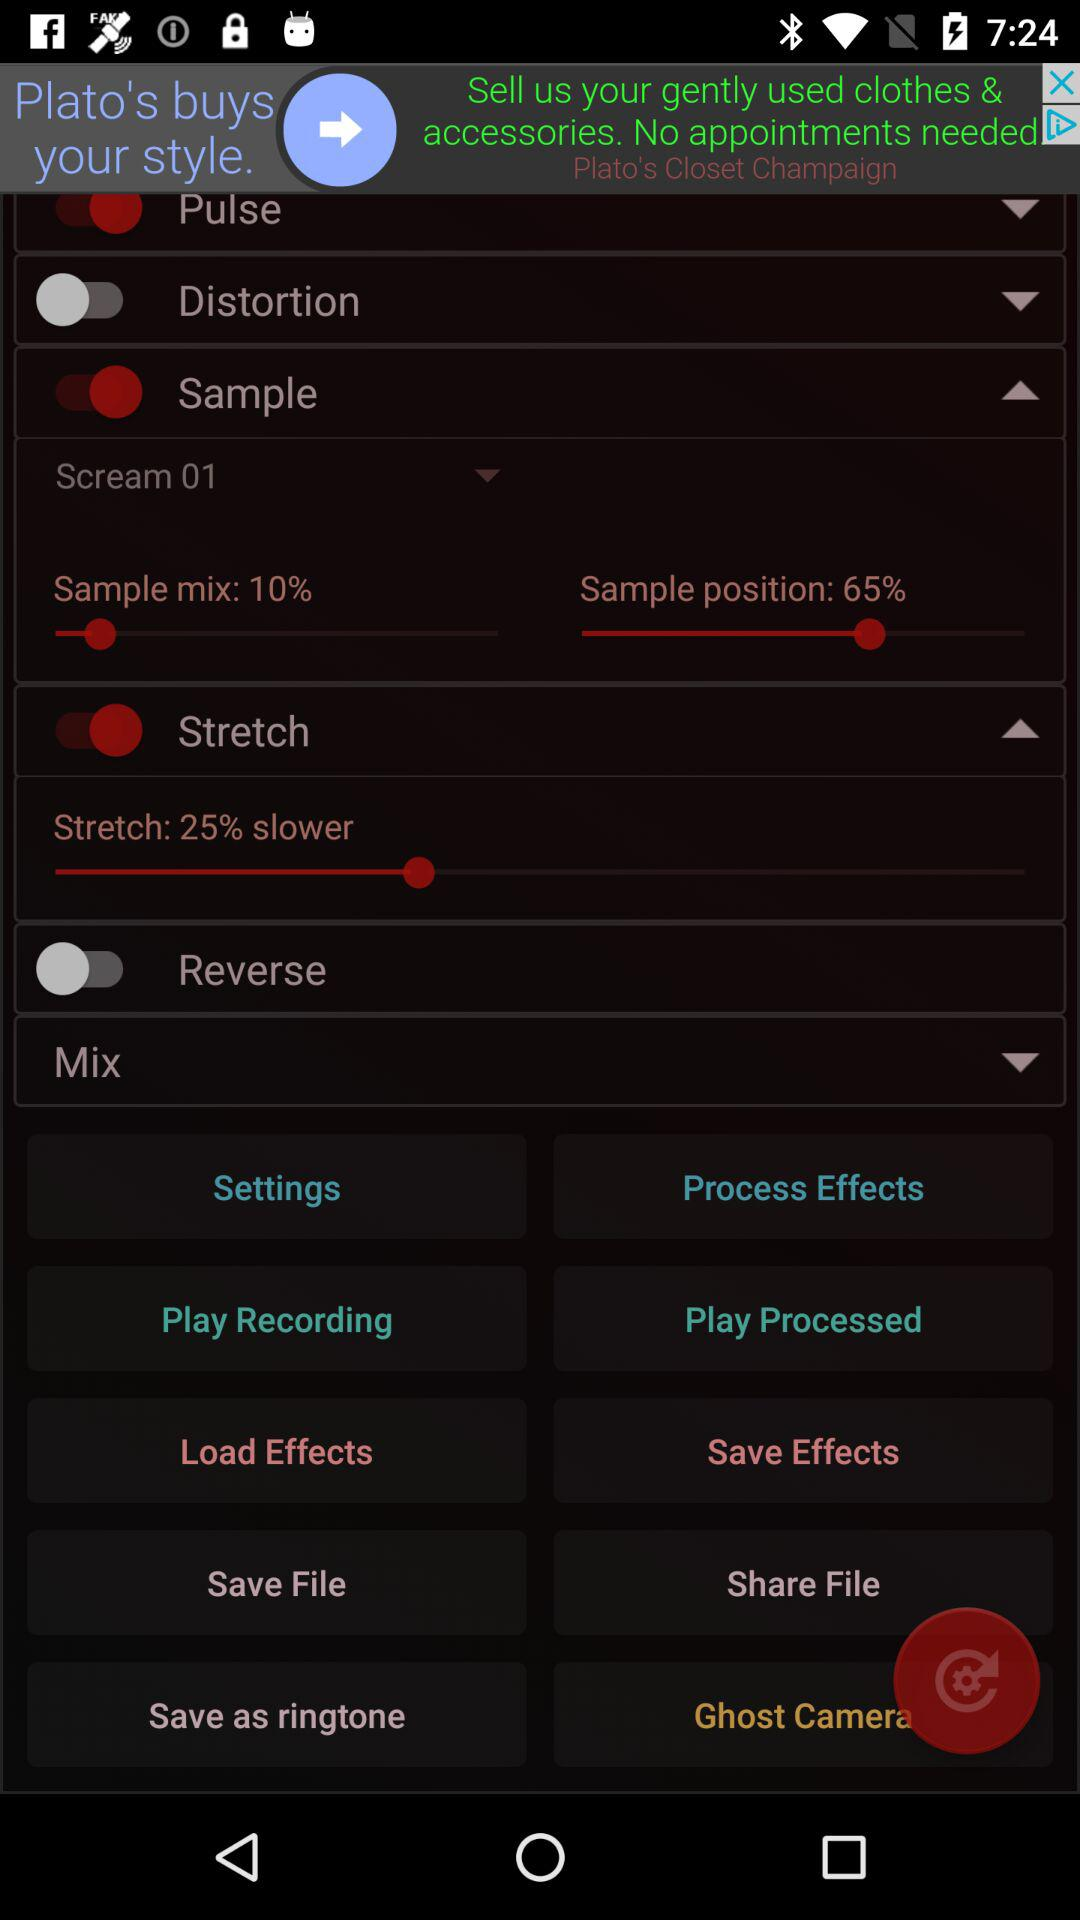What is the status of the "Reverse"? The status is off. 